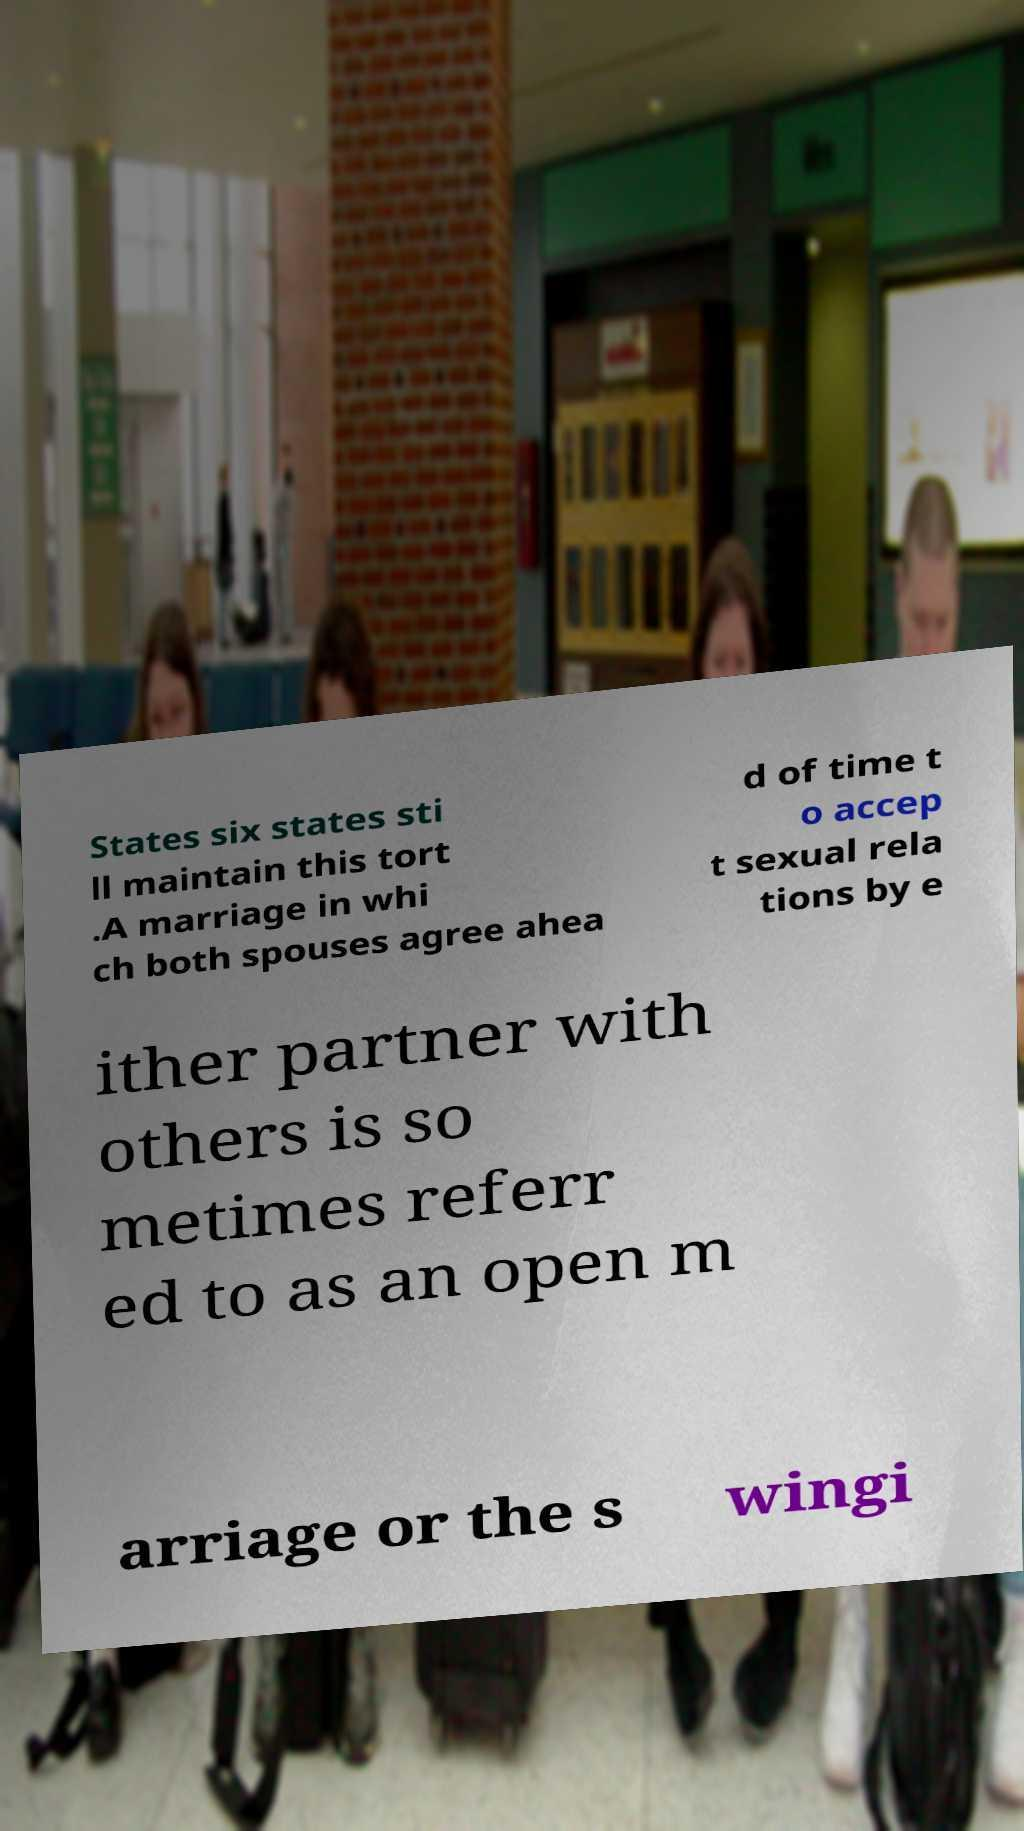Please read and relay the text visible in this image. What does it say? States six states sti ll maintain this tort .A marriage in whi ch both spouses agree ahea d of time t o accep t sexual rela tions by e ither partner with others is so metimes referr ed to as an open m arriage or the s wingi 